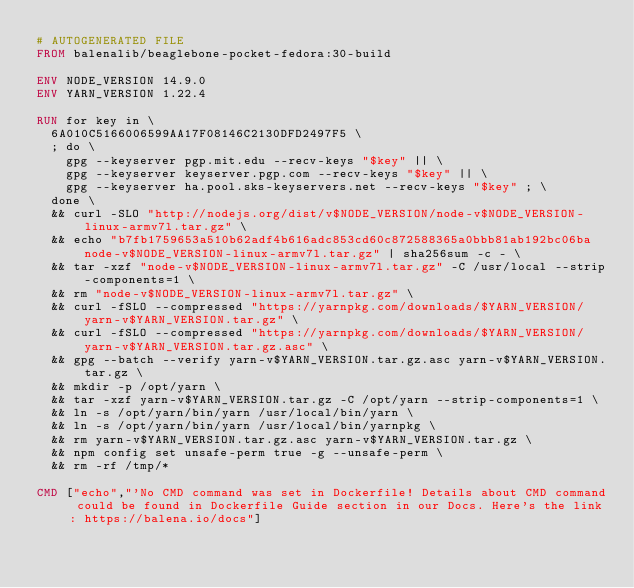Convert code to text. <code><loc_0><loc_0><loc_500><loc_500><_Dockerfile_># AUTOGENERATED FILE
FROM balenalib/beaglebone-pocket-fedora:30-build

ENV NODE_VERSION 14.9.0
ENV YARN_VERSION 1.22.4

RUN for key in \
	6A010C5166006599AA17F08146C2130DFD2497F5 \
	; do \
		gpg --keyserver pgp.mit.edu --recv-keys "$key" || \
		gpg --keyserver keyserver.pgp.com --recv-keys "$key" || \
		gpg --keyserver ha.pool.sks-keyservers.net --recv-keys "$key" ; \
	done \
	&& curl -SLO "http://nodejs.org/dist/v$NODE_VERSION/node-v$NODE_VERSION-linux-armv7l.tar.gz" \
	&& echo "b7fb1759653a510b62adf4b616adc853cd60c872588365a0bbb81ab192bc06ba  node-v$NODE_VERSION-linux-armv7l.tar.gz" | sha256sum -c - \
	&& tar -xzf "node-v$NODE_VERSION-linux-armv7l.tar.gz" -C /usr/local --strip-components=1 \
	&& rm "node-v$NODE_VERSION-linux-armv7l.tar.gz" \
	&& curl -fSLO --compressed "https://yarnpkg.com/downloads/$YARN_VERSION/yarn-v$YARN_VERSION.tar.gz" \
	&& curl -fSLO --compressed "https://yarnpkg.com/downloads/$YARN_VERSION/yarn-v$YARN_VERSION.tar.gz.asc" \
	&& gpg --batch --verify yarn-v$YARN_VERSION.tar.gz.asc yarn-v$YARN_VERSION.tar.gz \
	&& mkdir -p /opt/yarn \
	&& tar -xzf yarn-v$YARN_VERSION.tar.gz -C /opt/yarn --strip-components=1 \
	&& ln -s /opt/yarn/bin/yarn /usr/local/bin/yarn \
	&& ln -s /opt/yarn/bin/yarn /usr/local/bin/yarnpkg \
	&& rm yarn-v$YARN_VERSION.tar.gz.asc yarn-v$YARN_VERSION.tar.gz \
	&& npm config set unsafe-perm true -g --unsafe-perm \
	&& rm -rf /tmp/*

CMD ["echo","'No CMD command was set in Dockerfile! Details about CMD command could be found in Dockerfile Guide section in our Docs. Here's the link: https://balena.io/docs"]
</code> 